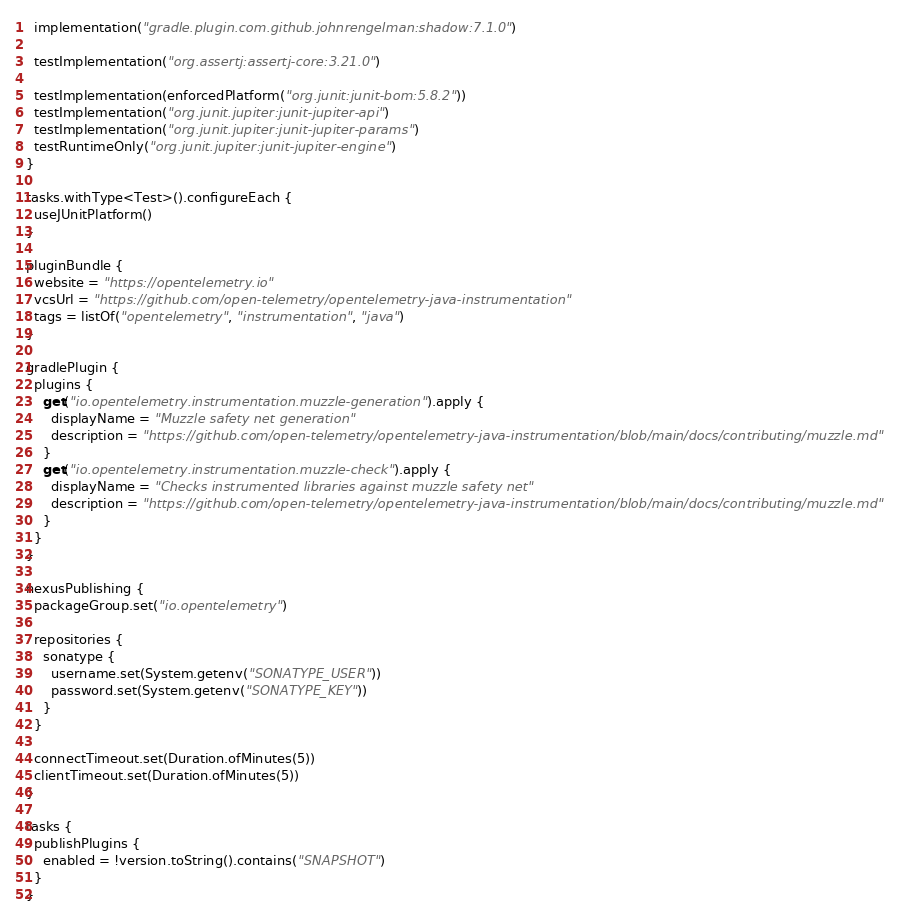Convert code to text. <code><loc_0><loc_0><loc_500><loc_500><_Kotlin_>
  implementation("gradle.plugin.com.github.johnrengelman:shadow:7.1.0")

  testImplementation("org.assertj:assertj-core:3.21.0")

  testImplementation(enforcedPlatform("org.junit:junit-bom:5.8.2"))
  testImplementation("org.junit.jupiter:junit-jupiter-api")
  testImplementation("org.junit.jupiter:junit-jupiter-params")
  testRuntimeOnly("org.junit.jupiter:junit-jupiter-engine")
}

tasks.withType<Test>().configureEach {
  useJUnitPlatform()
}

pluginBundle {
  website = "https://opentelemetry.io"
  vcsUrl = "https://github.com/open-telemetry/opentelemetry-java-instrumentation"
  tags = listOf("opentelemetry", "instrumentation", "java")
}

gradlePlugin {
  plugins {
    get("io.opentelemetry.instrumentation.muzzle-generation").apply {
      displayName = "Muzzle safety net generation"
      description = "https://github.com/open-telemetry/opentelemetry-java-instrumentation/blob/main/docs/contributing/muzzle.md"
    }
    get("io.opentelemetry.instrumentation.muzzle-check").apply {
      displayName = "Checks instrumented libraries against muzzle safety net"
      description = "https://github.com/open-telemetry/opentelemetry-java-instrumentation/blob/main/docs/contributing/muzzle.md"
    }
  }
}

nexusPublishing {
  packageGroup.set("io.opentelemetry")

  repositories {
    sonatype {
      username.set(System.getenv("SONATYPE_USER"))
      password.set(System.getenv("SONATYPE_KEY"))
    }
  }

  connectTimeout.set(Duration.ofMinutes(5))
  clientTimeout.set(Duration.ofMinutes(5))
}

tasks {
  publishPlugins {
    enabled = !version.toString().contains("SNAPSHOT")
  }
}
</code> 